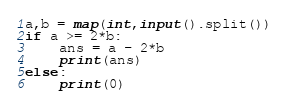Convert code to text. <code><loc_0><loc_0><loc_500><loc_500><_Python_>a,b = map(int,input().split())
if a >= 2*b:
    ans = a - 2*b
    print(ans)
else:
    print(0)
</code> 